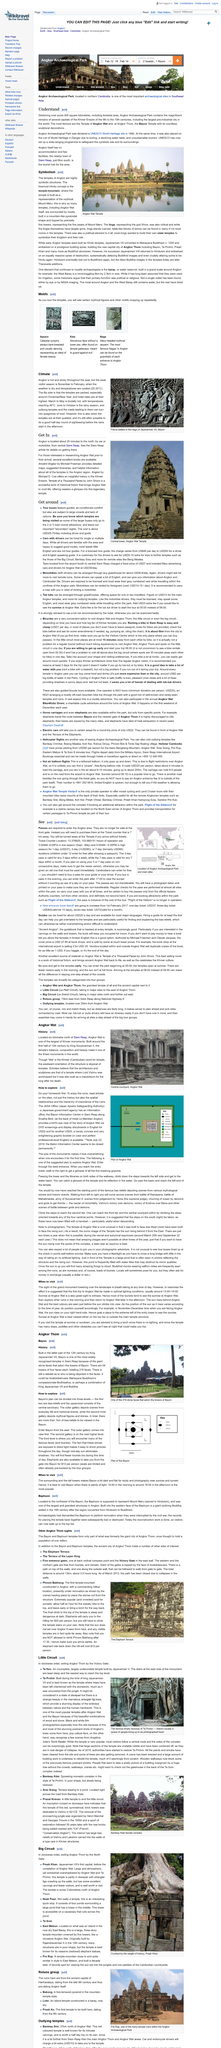Give some essential details in this illustration. The above picture depicts scenes of intense warfare during the reign of Jayavarman VII, showcasing the bravery and strength of the Khmer army. The image depicts a monument known as Angkor Wat, which is a significant historical and cultural landmark. Preah Khan is located approximately 3 kilometers north of Angkor Thom. The months of June to October are the ones in which it rains the most in Angkor. Neak Pean is a man-made temple in Cambodia that is formed by four smaller ponds surrounding a central larger pond, which is connected to a tower in the center. 